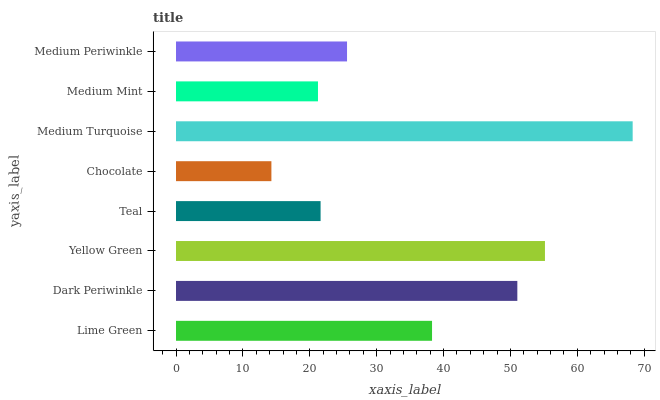Is Chocolate the minimum?
Answer yes or no. Yes. Is Medium Turquoise the maximum?
Answer yes or no. Yes. Is Dark Periwinkle the minimum?
Answer yes or no. No. Is Dark Periwinkle the maximum?
Answer yes or no. No. Is Dark Periwinkle greater than Lime Green?
Answer yes or no. Yes. Is Lime Green less than Dark Periwinkle?
Answer yes or no. Yes. Is Lime Green greater than Dark Periwinkle?
Answer yes or no. No. Is Dark Periwinkle less than Lime Green?
Answer yes or no. No. Is Lime Green the high median?
Answer yes or no. Yes. Is Medium Periwinkle the low median?
Answer yes or no. Yes. Is Medium Periwinkle the high median?
Answer yes or no. No. Is Teal the low median?
Answer yes or no. No. 